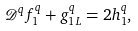<formula> <loc_0><loc_0><loc_500><loc_500>\mathcal { D } ^ { q } f _ { 1 } ^ { q } + g _ { 1 L } ^ { q } = 2 h _ { 1 } ^ { q } ,</formula> 